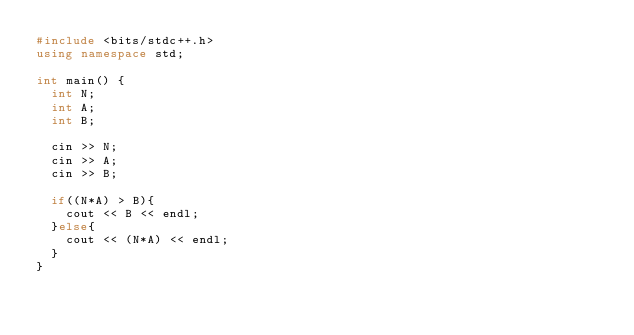Convert code to text. <code><loc_0><loc_0><loc_500><loc_500><_C++_>#include <bits/stdc++.h>
using namespace std;

int main() {
  int N;
  int A;
  int B;
  
  cin >> N;
  cin >> A;
  cin >> B;
  
  if((N*A) > B){
    cout << B << endl;
  }else{
    cout << (N*A) << endl;
  }
}
</code> 